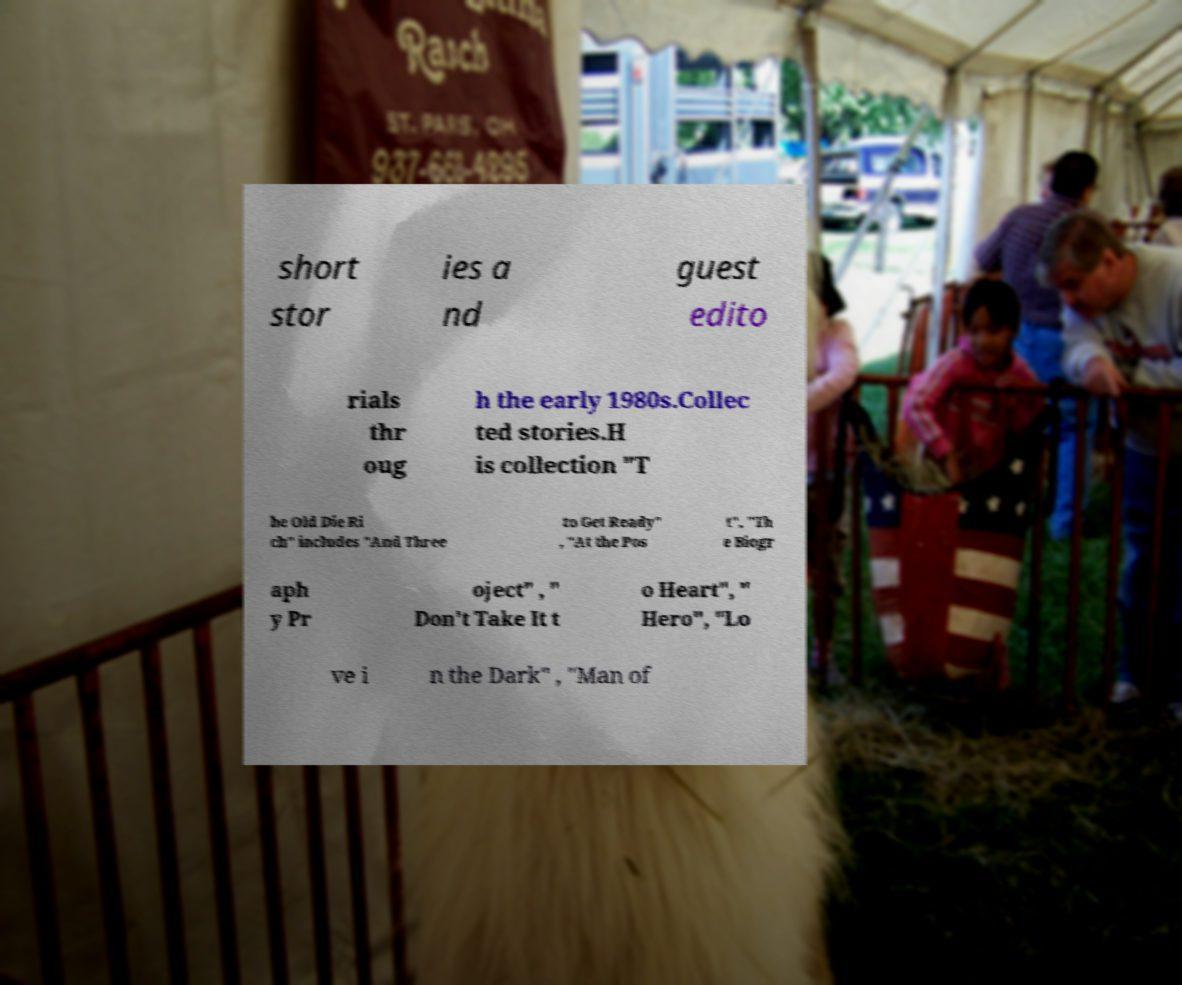Please identify and transcribe the text found in this image. short stor ies a nd guest edito rials thr oug h the early 1980s.Collec ted stories.H is collection "T he Old Die Ri ch" includes "And Three to Get Ready" , "At the Pos t", "Th e Biogr aph y Pr oject" , " Don't Take It t o Heart", " Hero", "Lo ve i n the Dark" , "Man of 